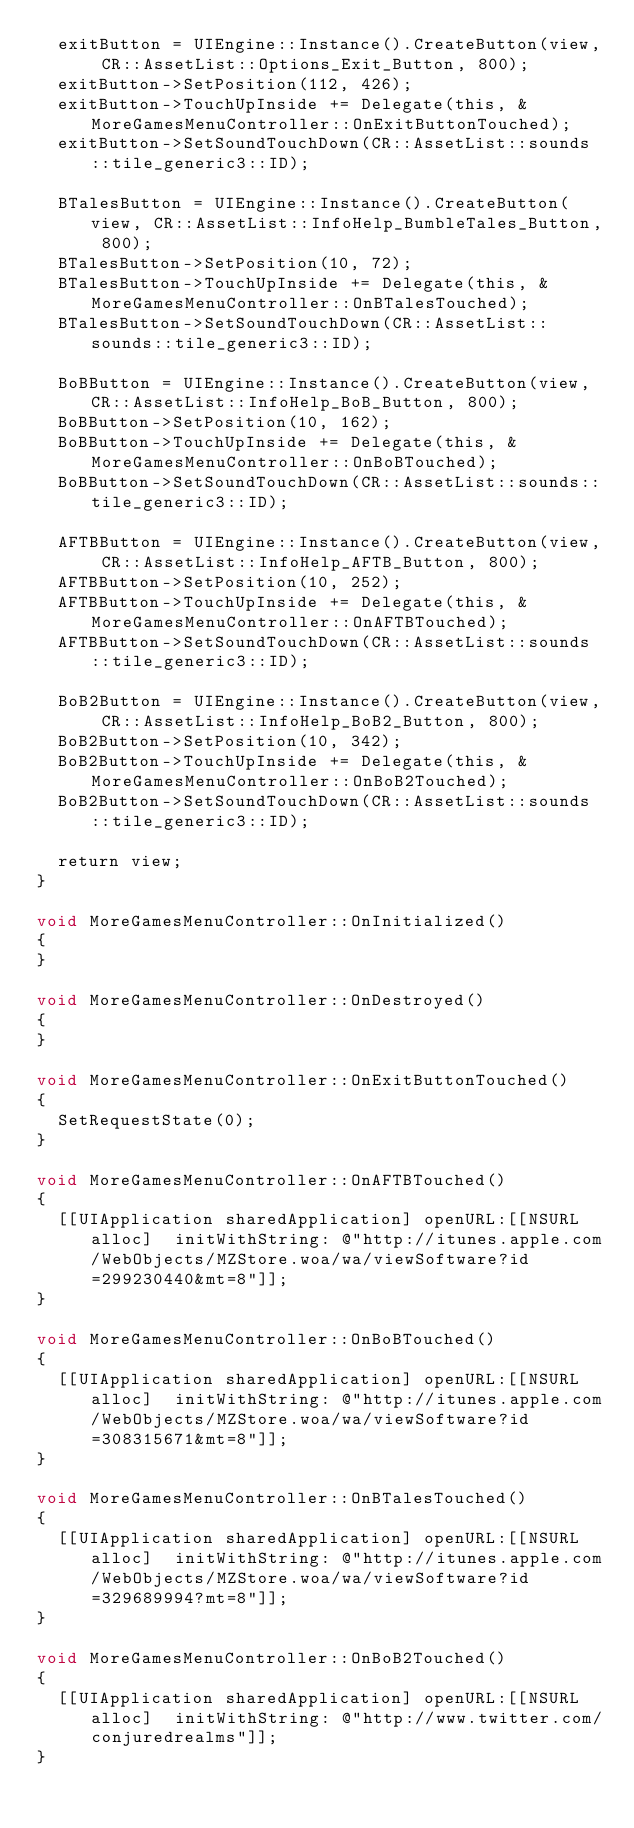<code> <loc_0><loc_0><loc_500><loc_500><_ObjectiveC_>	exitButton = UIEngine::Instance().CreateButton(view, CR::AssetList::Options_Exit_Button, 800);
	exitButton->SetPosition(112, 426);
	exitButton->TouchUpInside += Delegate(this, &MoreGamesMenuController::OnExitButtonTouched);
	exitButton->SetSoundTouchDown(CR::AssetList::sounds::tile_generic3::ID);
	
	BTalesButton = UIEngine::Instance().CreateButton(view, CR::AssetList::InfoHelp_BumbleTales_Button, 800);
	BTalesButton->SetPosition(10, 72);
	BTalesButton->TouchUpInside += Delegate(this, &MoreGamesMenuController::OnBTalesTouched);
	BTalesButton->SetSoundTouchDown(CR::AssetList::sounds::tile_generic3::ID);
	
	BoBButton = UIEngine::Instance().CreateButton(view, CR::AssetList::InfoHelp_BoB_Button, 800);
	BoBButton->SetPosition(10, 162);
	BoBButton->TouchUpInside += Delegate(this, &MoreGamesMenuController::OnBoBTouched);
	BoBButton->SetSoundTouchDown(CR::AssetList::sounds::tile_generic3::ID);
	
	AFTBButton = UIEngine::Instance().CreateButton(view, CR::AssetList::InfoHelp_AFTB_Button, 800);
	AFTBButton->SetPosition(10, 252);
	AFTBButton->TouchUpInside += Delegate(this, &MoreGamesMenuController::OnAFTBTouched);
	AFTBButton->SetSoundTouchDown(CR::AssetList::sounds::tile_generic3::ID);
	
	BoB2Button = UIEngine::Instance().CreateButton(view, CR::AssetList::InfoHelp_BoB2_Button, 800);
	BoB2Button->SetPosition(10, 342);
	BoB2Button->TouchUpInside += Delegate(this, &MoreGamesMenuController::OnBoB2Touched);
	BoB2Button->SetSoundTouchDown(CR::AssetList::sounds::tile_generic3::ID);
	
	return view;
}

void MoreGamesMenuController::OnInitialized()
{
}

void MoreGamesMenuController::OnDestroyed()
{
}

void MoreGamesMenuController::OnExitButtonTouched()
{
	SetRequestState(0);
}

void MoreGamesMenuController::OnAFTBTouched()
{
	[[UIApplication sharedApplication] openURL:[[NSURL alloc]  initWithString: @"http://itunes.apple.com/WebObjects/MZStore.woa/wa/viewSoftware?id=299230440&mt=8"]];
}

void MoreGamesMenuController::OnBoBTouched()
{
	[[UIApplication sharedApplication] openURL:[[NSURL alloc]  initWithString: @"http://itunes.apple.com/WebObjects/MZStore.woa/wa/viewSoftware?id=308315671&mt=8"]];
}

void MoreGamesMenuController::OnBTalesTouched()
{
	[[UIApplication sharedApplication] openURL:[[NSURL alloc]  initWithString: @"http://itunes.apple.com/WebObjects/MZStore.woa/wa/viewSoftware?id=329689994?mt=8"]];
}

void MoreGamesMenuController::OnBoB2Touched()
{
	[[UIApplication sharedApplication] openURL:[[NSURL alloc]  initWithString: @"http://www.twitter.com/conjuredrealms"]];
}</code> 